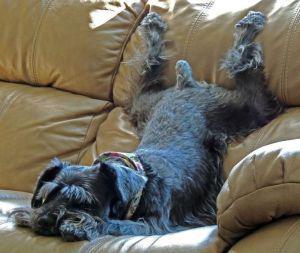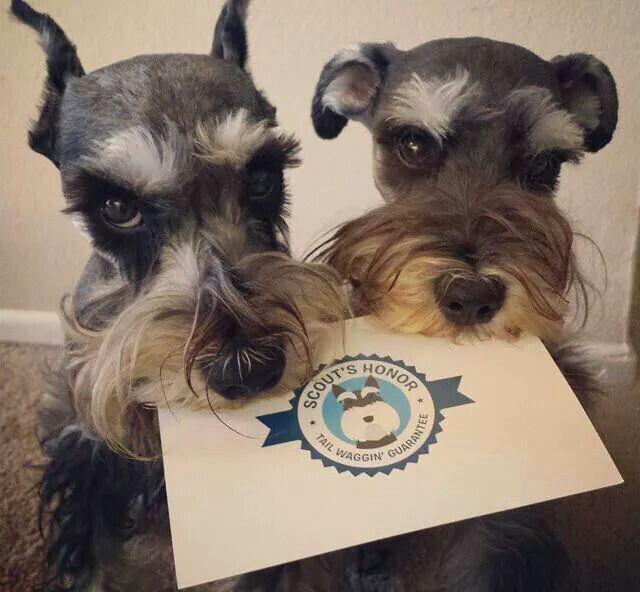The first image is the image on the left, the second image is the image on the right. Analyze the images presented: Is the assertion "There are more dogs in the image on the right." valid? Answer yes or no. Yes. 